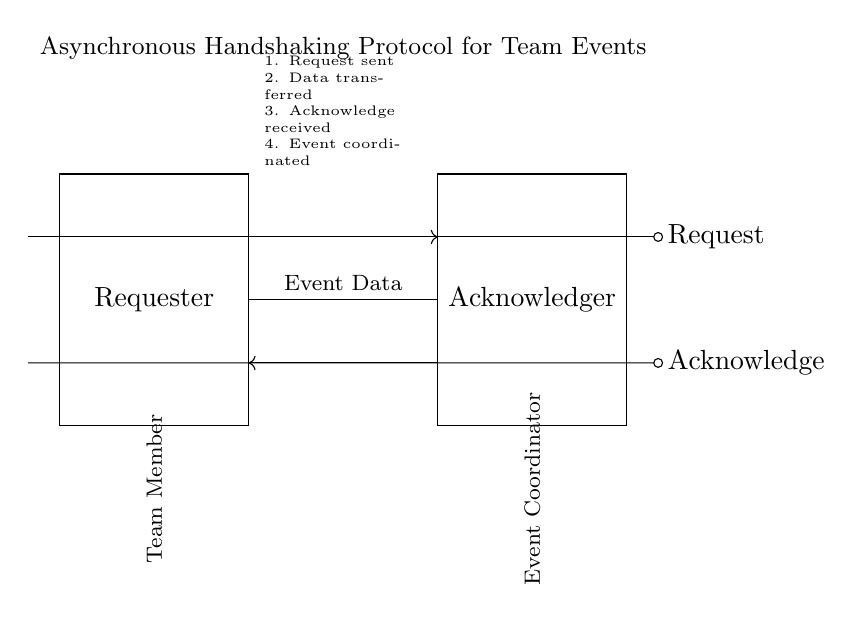What are the two main blocks in the circuit? The two main blocks are labeled as "Requester" and "Acknowledger." They represent the entities involved in the handshaking protocol.
Answer: Requester, Acknowledger What is the purpose of the Request line? The Request line indicates a request signal sent from the Requester to the Acknowledger to initiate communication for coordinating an activity or event.
Answer: Initiate communication What is transferred along the Event Data line? The Event Data line carries the specific details about the event being coordinated between the Requester and Acknowledger.
Answer: Event details How many steps are involved in the protocol? The protocol consists of four steps, which are outlined in the circuit diagram. They detail the process from requesting to completing the event coordination.
Answer: Four steps What kind of protocol is depicted in the circuit? The circuit diagram depicts an asynchronous handshaking protocol, which allows for communication without requiring both parties to be in sync at the same time.
Answer: Asynchronous What signal is sent from the Requester to the Acknowledger? The request signal is the one sent from the Requester to the Acknowledger, initiating the data transfer process.
Answer: Request signal 